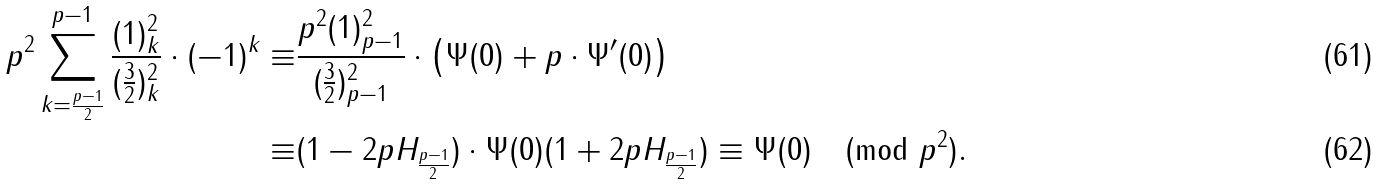<formula> <loc_0><loc_0><loc_500><loc_500>p ^ { 2 } \sum _ { k = \frac { p - 1 } 2 } ^ { p - 1 } \frac { ( 1 ) _ { k } ^ { 2 } } { ( \frac { 3 } { 2 } ) _ { k } ^ { 2 } } \cdot ( - 1 ) ^ { k } \equiv & \frac { p ^ { 2 } ( 1 ) _ { p - 1 } ^ { 2 } } { ( \frac { 3 } { 2 } ) _ { p - 1 } ^ { 2 } } \cdot \left ( \Psi ( 0 ) + p \cdot \Psi ^ { \prime } ( 0 ) \right ) \\ \equiv & ( 1 - 2 p H _ { \frac { p - 1 } 2 } ) \cdot \Psi ( 0 ) ( 1 + 2 p H _ { \frac { p - 1 } 2 } ) \equiv \Psi ( 0 ) \pmod { p ^ { 2 } } .</formula> 